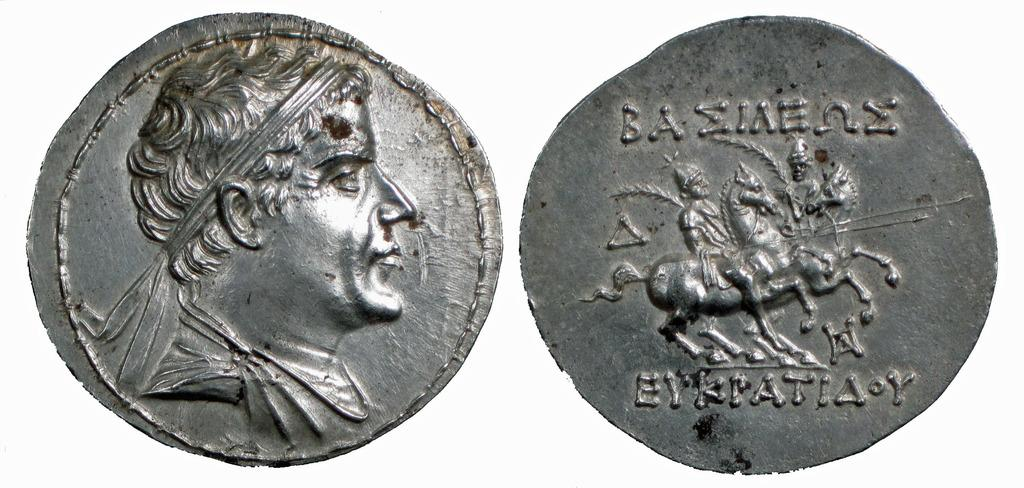<image>
Summarize the visual content of the image. The front and back of an old coin on which EYKPATIA is written. 